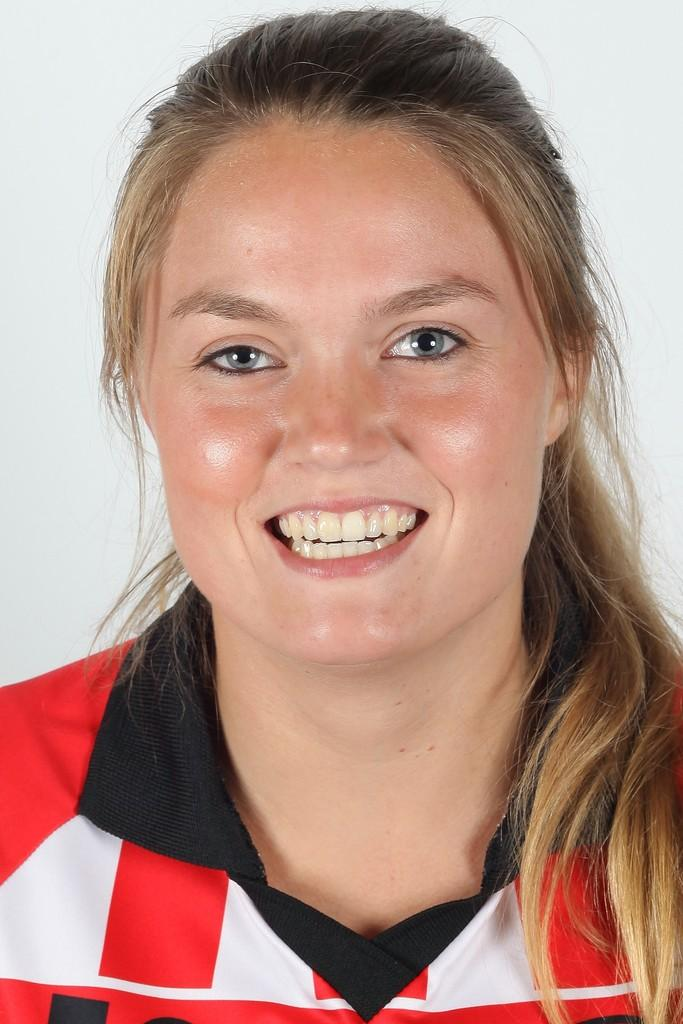Who is present in the image? There is a woman in the image. What is the woman's facial expression? The woman is smiling. What color is the background of the image? The background of the image is white. What effect does the wind have on the woman's hair in the image? There is no wind present in the image, so it cannot have any effect on the woman's hair. 